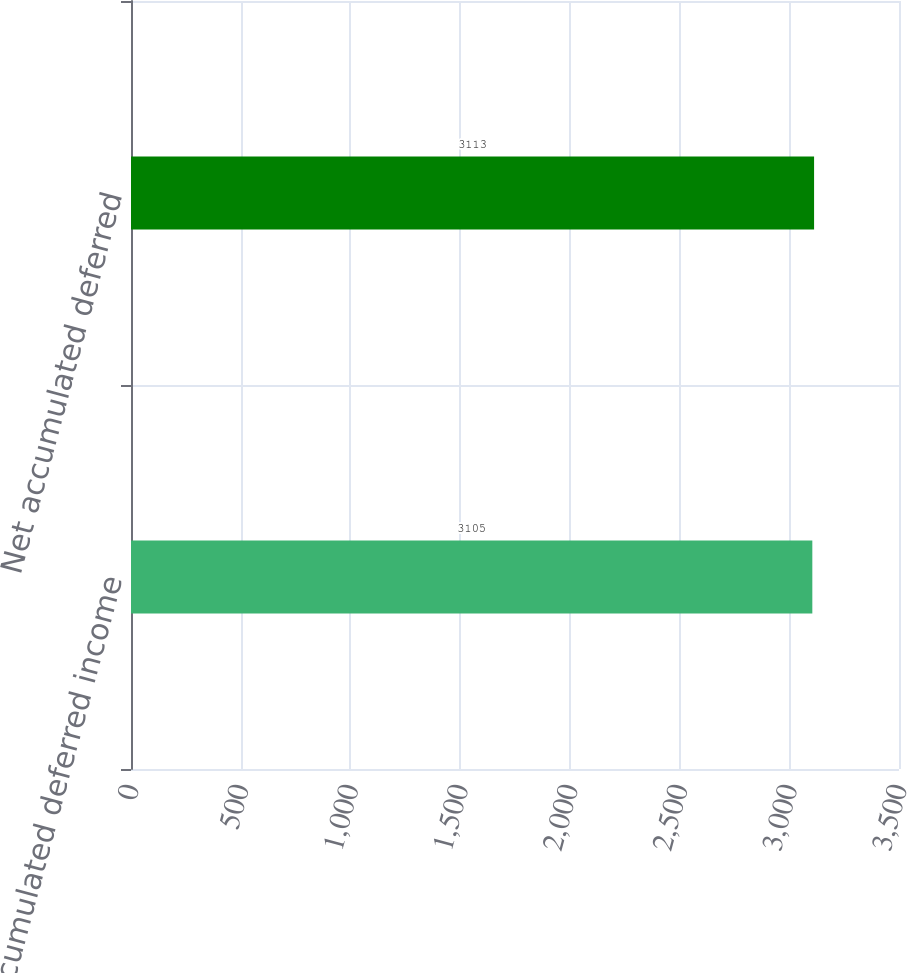Convert chart. <chart><loc_0><loc_0><loc_500><loc_500><bar_chart><fcel>Accumulated deferred income<fcel>Net accumulated deferred<nl><fcel>3105<fcel>3113<nl></chart> 